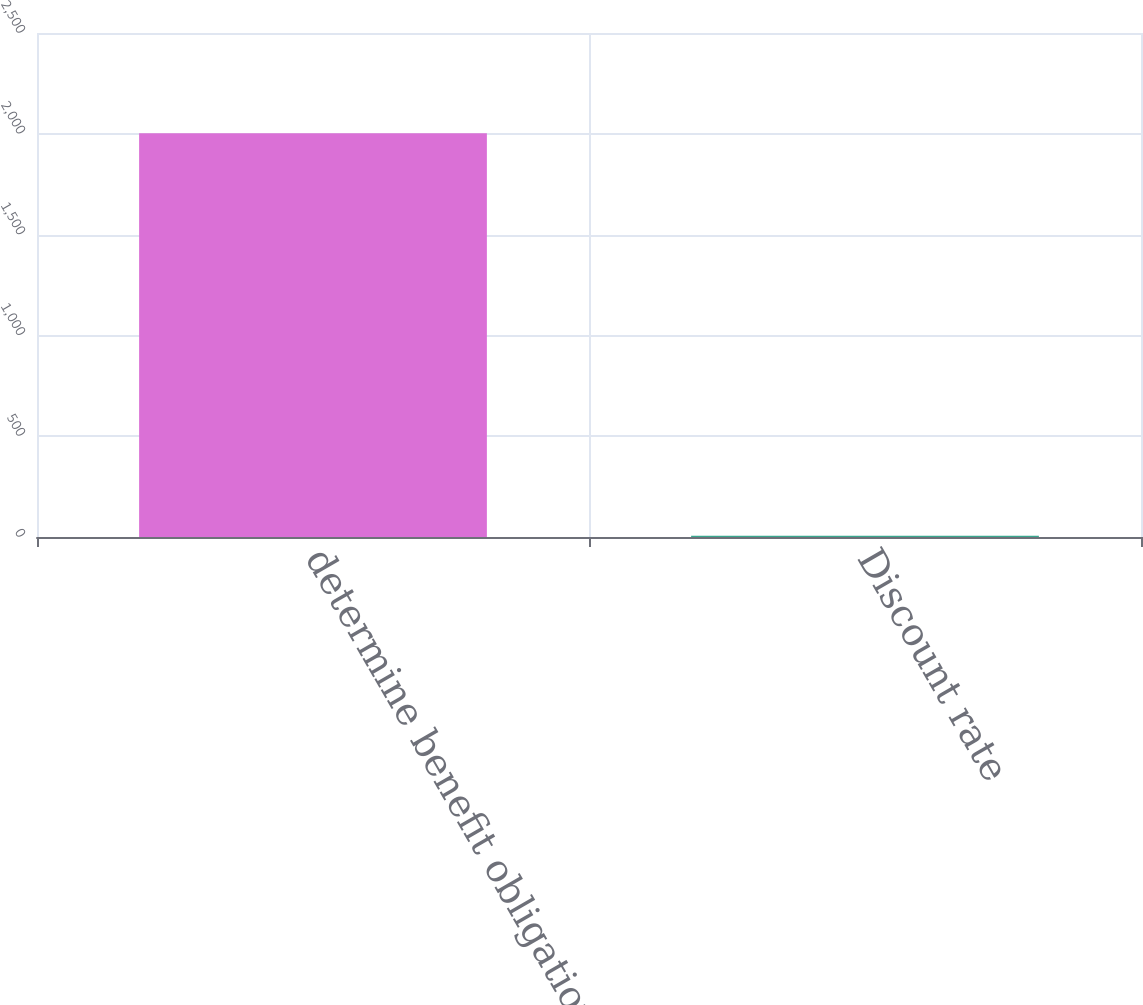<chart> <loc_0><loc_0><loc_500><loc_500><bar_chart><fcel>determine benefit obligations<fcel>Discount rate<nl><fcel>2003<fcel>6.25<nl></chart> 